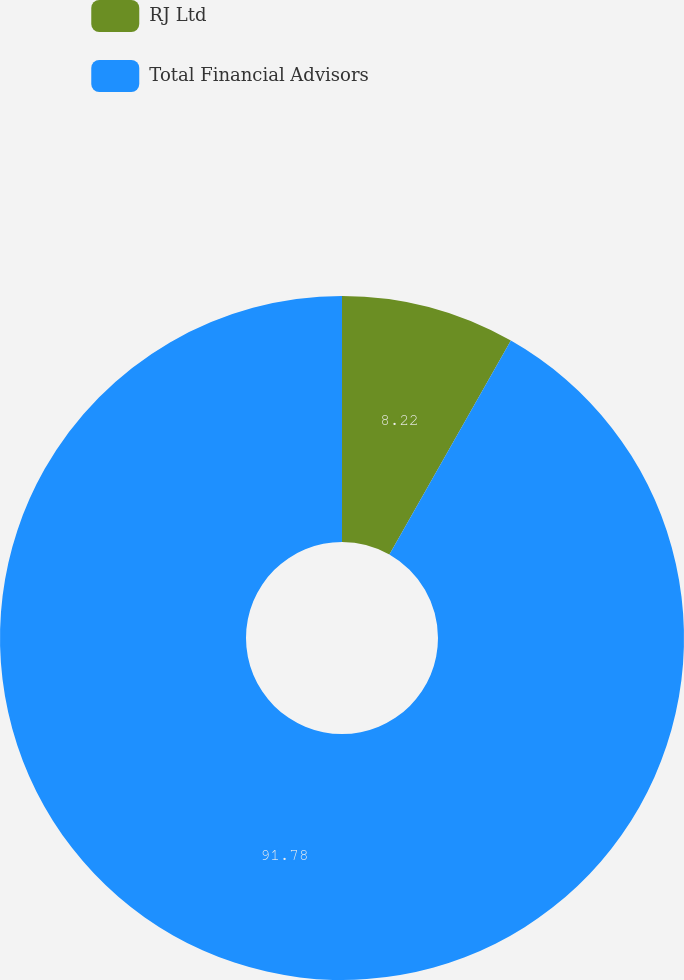Convert chart to OTSL. <chart><loc_0><loc_0><loc_500><loc_500><pie_chart><fcel>RJ Ltd<fcel>Total Financial Advisors<nl><fcel>8.22%<fcel>91.78%<nl></chart> 